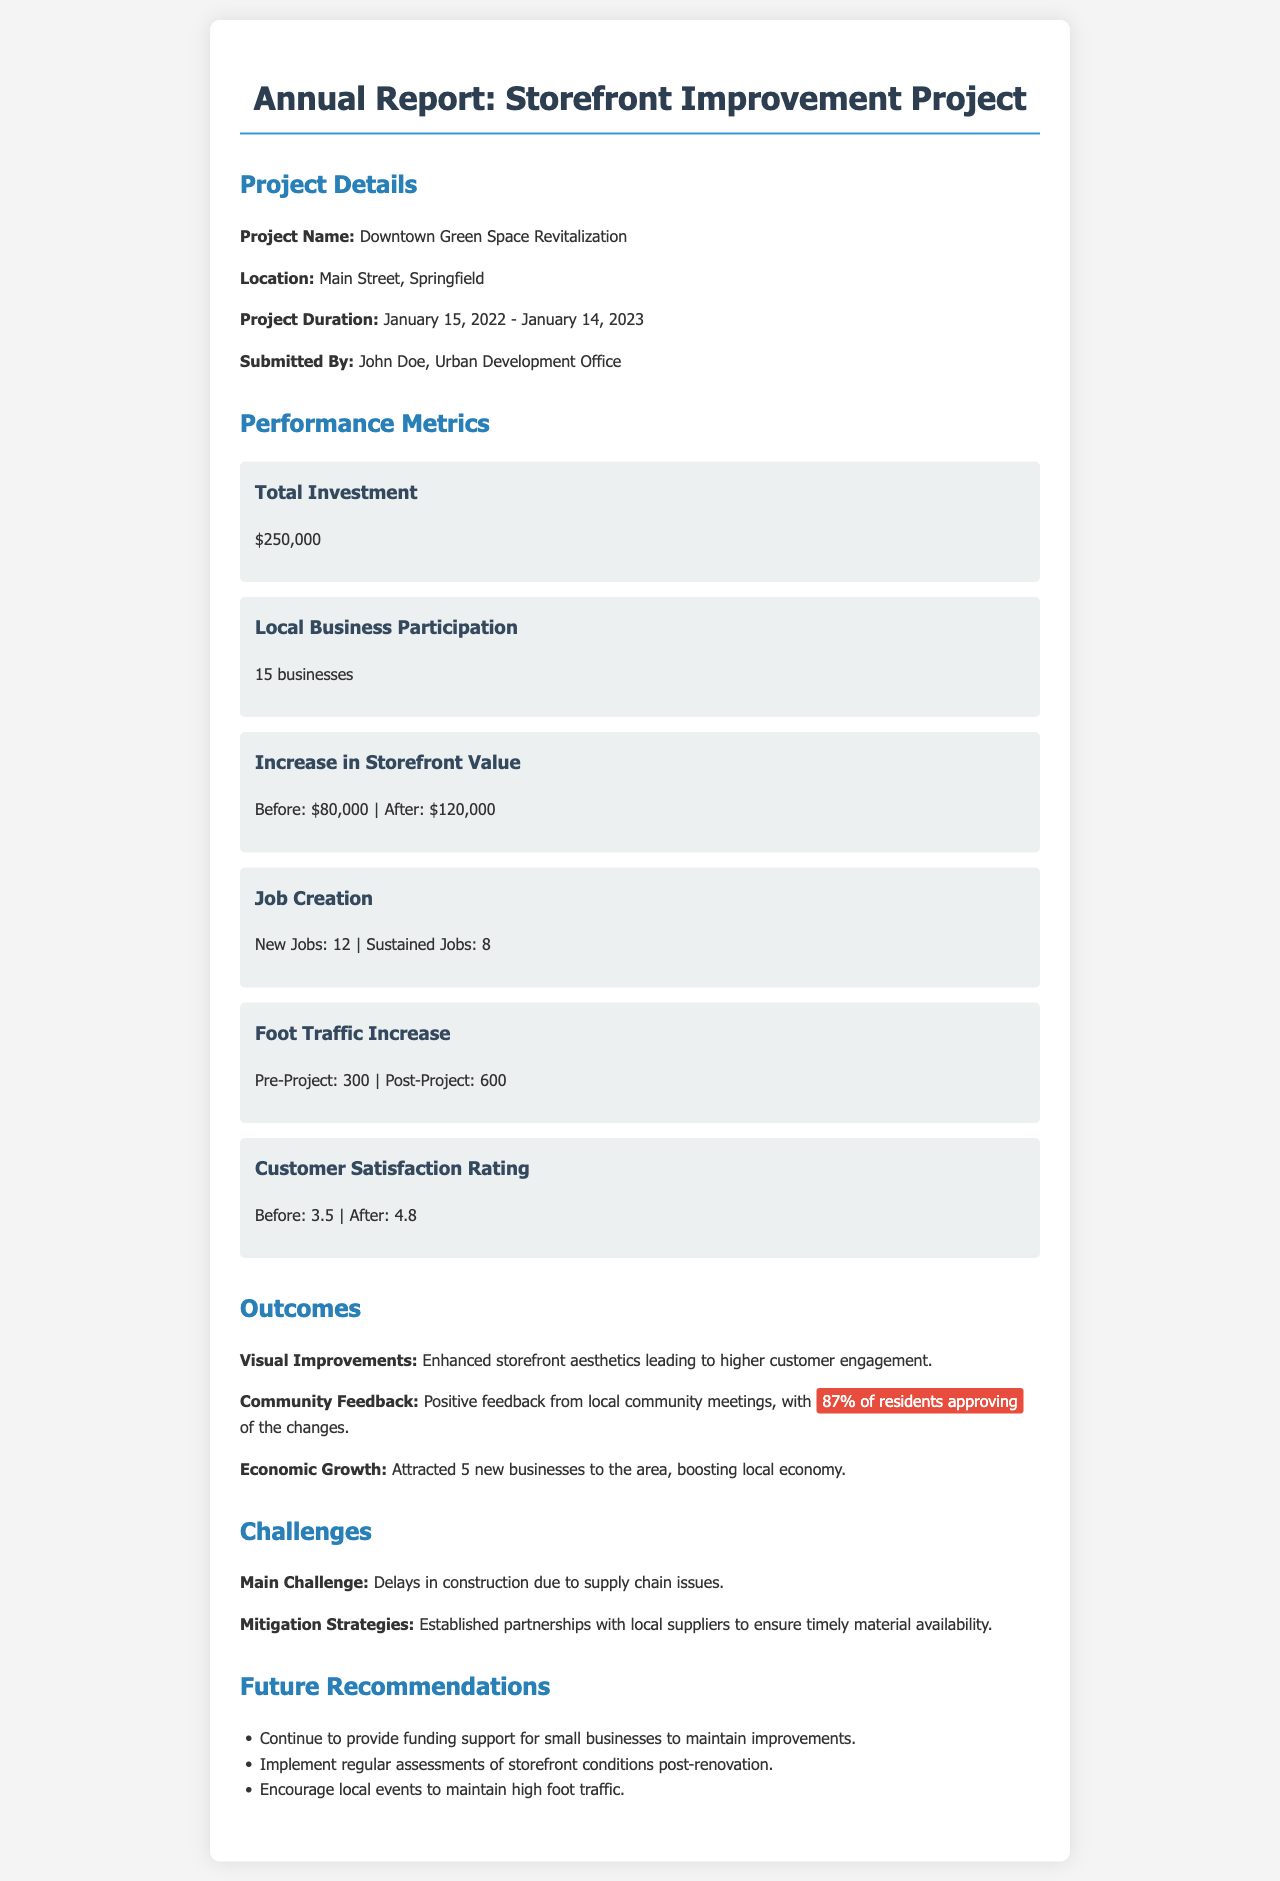What is the project name? The project name is listed at the beginning of the project details section.
Answer: Downtown Green Space Revitalization What is the total investment amount? The total investment amount is specified under the performance metrics section.
Answer: $250,000 How many businesses participated in the project? The number of local businesses participation is mentioned in the performance metrics.
Answer: 15 businesses What percentage of residents approved the changes? The approval percentage is highlighted in the community feedback subsection under outcomes.
Answer: 87% What was the customer satisfaction rating before the project? The customer satisfaction rating before the project is specified in the performance metrics.
Answer: Before: 3.5 What was the pre-project foot traffic? The pre-project foot traffic is indicated in the performance metrics section.
Answer: 300 What was the main challenge faced during the project? The main challenge is mentioned in the challenges section of the document.
Answer: Delays in construction What is one of the recommendations for future improvements? The recommendations for future improvements are listed in the future recommendations section.
Answer: Provide funding support for small businesses 